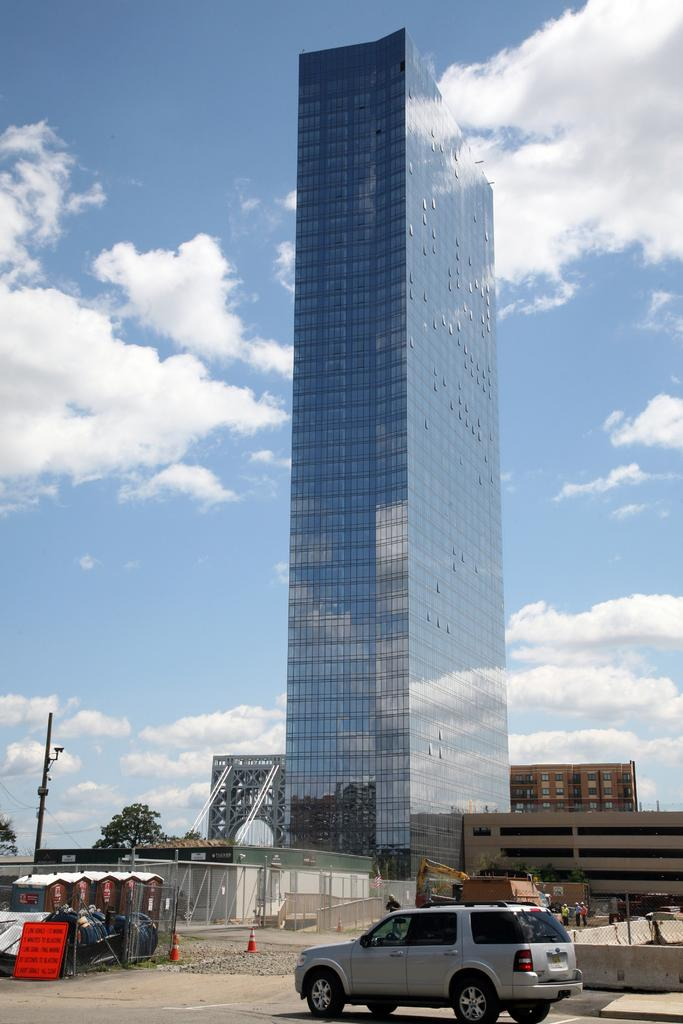What is the main subject in the center of the image? There is a building in the center of the image. What else can be seen at the bottom of the image? There are buildings at the bottom of the image. Can you describe any other objects in the image? There is a pole, a cat, a road, and a traffic cone in the image. What is visible in the background of the image? The sky is visible in the background of the image, and there are clouds present. What type of wool is the snake using to knit a scarf in the image? There is no snake or wool present in the image. Who is the partner of the cat in the image? There is no partner mentioned or implied in the image; it only features a cat and other objects. 